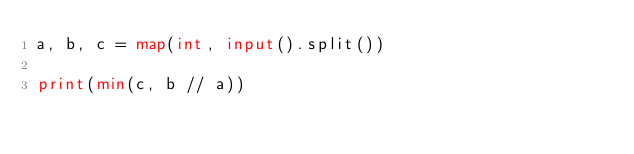<code> <loc_0><loc_0><loc_500><loc_500><_Python_>a, b, c = map(int, input().split())

print(min(c, b // a))</code> 